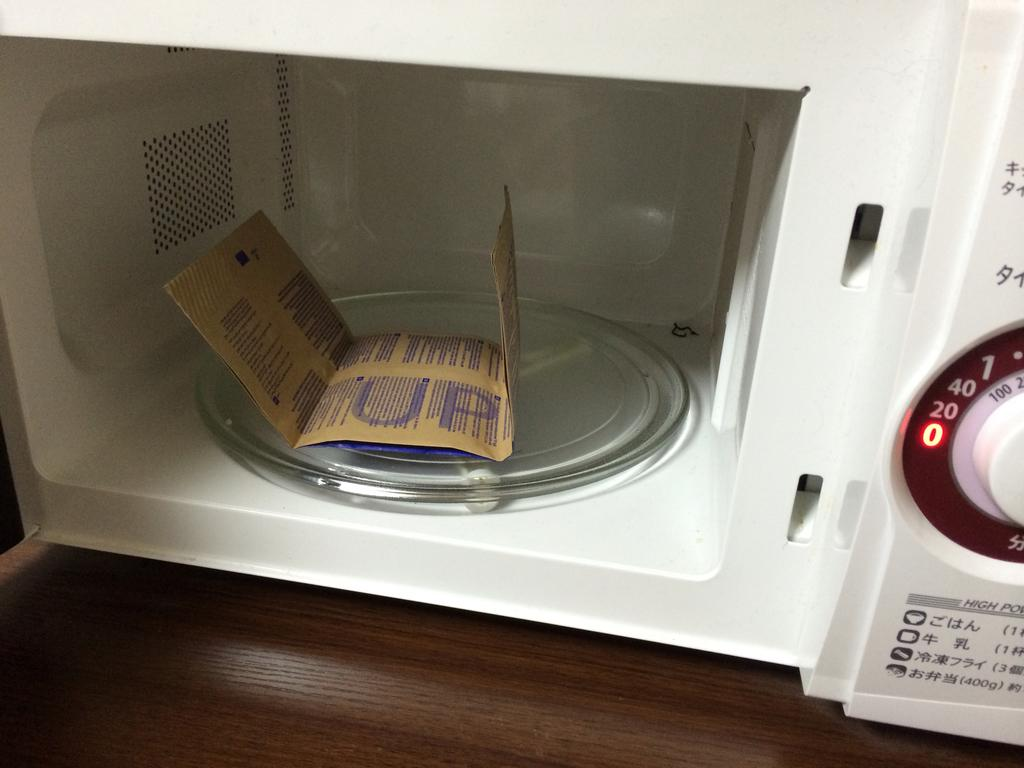<image>
Give a short and clear explanation of the subsequent image. A packet of food is sitting in a microwave that is current at Zero 